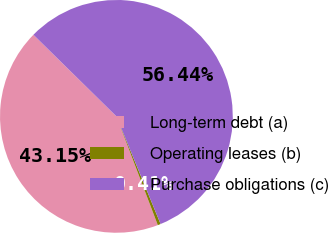Convert chart to OTSL. <chart><loc_0><loc_0><loc_500><loc_500><pie_chart><fcel>Long-term debt (a)<fcel>Operating leases (b)<fcel>Purchase obligations (c)<nl><fcel>43.15%<fcel>0.41%<fcel>56.43%<nl></chart> 